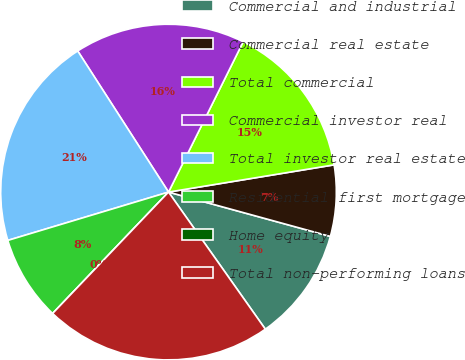<chart> <loc_0><loc_0><loc_500><loc_500><pie_chart><fcel>Commercial and industrial<fcel>Commercial real estate<fcel>Total commercial<fcel>Commercial investor real<fcel>Total investor real estate<fcel>Residential first mortgage<fcel>Home equity<fcel>Total non-performing loans<nl><fcel>10.96%<fcel>6.85%<fcel>15.07%<fcel>16.44%<fcel>20.55%<fcel>8.22%<fcel>0.0%<fcel>21.92%<nl></chart> 